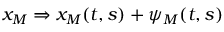<formula> <loc_0><loc_0><loc_500><loc_500>x _ { M } \Rightarrow x _ { M } ( t , s ) + \psi _ { M } ( t , s )</formula> 